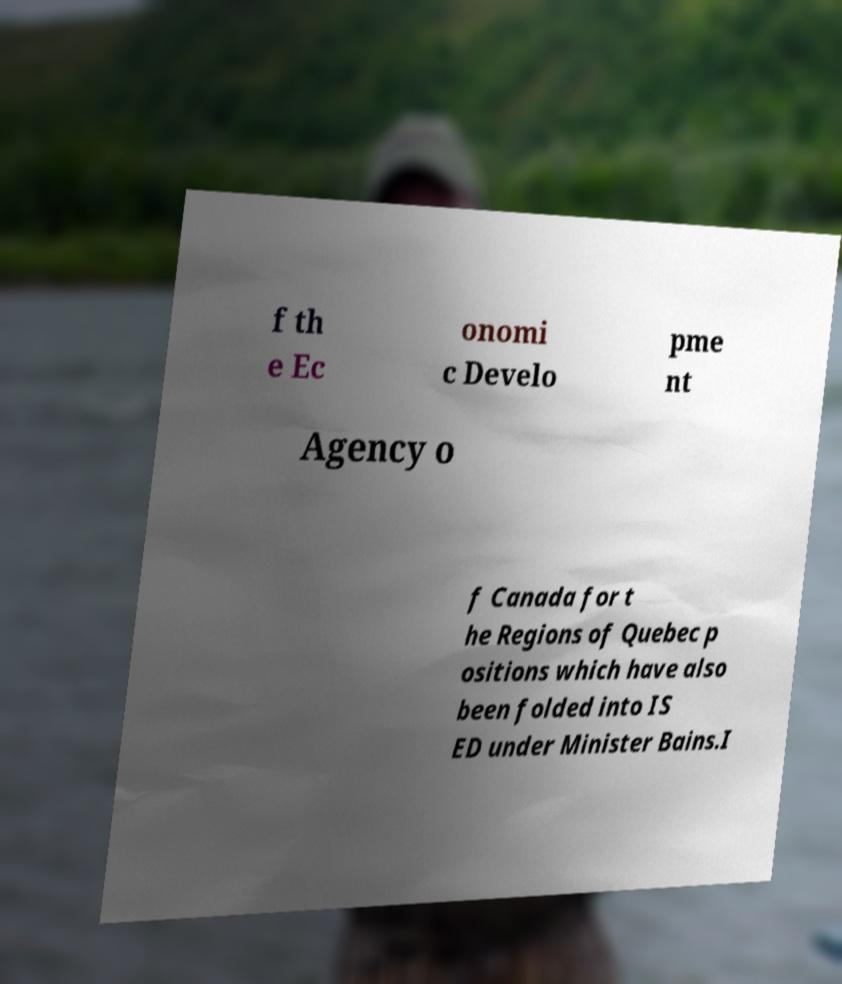Please identify and transcribe the text found in this image. f th e Ec onomi c Develo pme nt Agency o f Canada for t he Regions of Quebec p ositions which have also been folded into IS ED under Minister Bains.I 